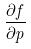<formula> <loc_0><loc_0><loc_500><loc_500>\frac { \partial f } { \partial p }</formula> 